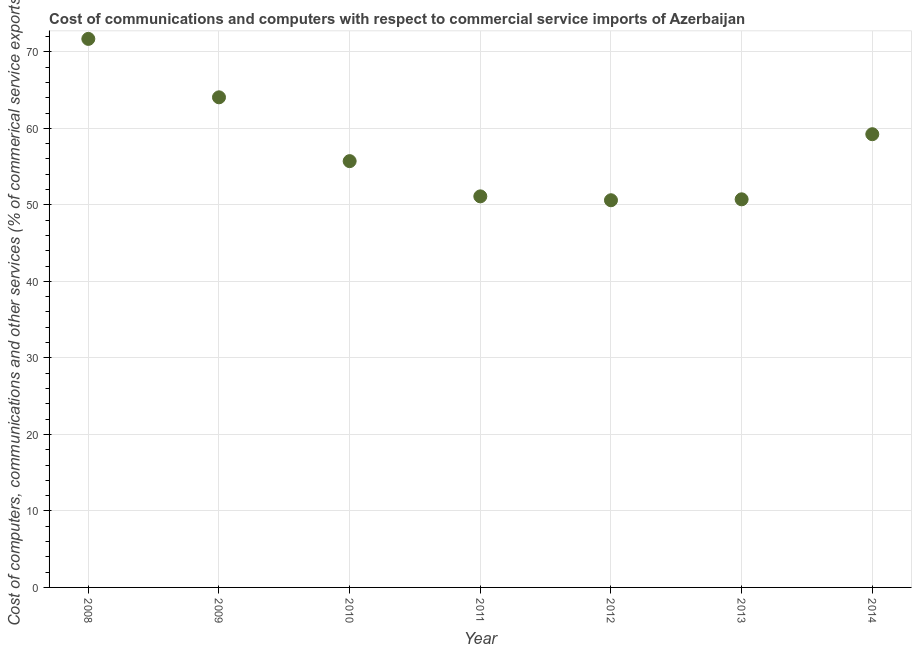What is the cost of communications in 2012?
Your answer should be very brief. 50.6. Across all years, what is the maximum cost of communications?
Provide a succinct answer. 71.69. Across all years, what is the minimum cost of communications?
Your response must be concise. 50.6. In which year was the cost of communications maximum?
Keep it short and to the point. 2008. In which year was the cost of communications minimum?
Provide a short and direct response. 2012. What is the sum of the  computer and other services?
Your answer should be very brief. 403.13. What is the difference between the  computer and other services in 2011 and 2014?
Offer a terse response. -8.12. What is the average  computer and other services per year?
Your response must be concise. 57.59. What is the median  computer and other services?
Your answer should be compact. 55.71. In how many years, is the  computer and other services greater than 52 %?
Offer a very short reply. 4. Do a majority of the years between 2011 and 2013 (inclusive) have  computer and other services greater than 46 %?
Ensure brevity in your answer.  Yes. What is the ratio of the cost of communications in 2013 to that in 2014?
Your answer should be very brief. 0.86. Is the  computer and other services in 2008 less than that in 2010?
Make the answer very short. No. What is the difference between the highest and the second highest cost of communications?
Keep it short and to the point. 7.64. Is the sum of the  computer and other services in 2010 and 2011 greater than the maximum  computer and other services across all years?
Keep it short and to the point. Yes. What is the difference between the highest and the lowest  computer and other services?
Provide a short and direct response. 21.09. In how many years, is the  computer and other services greater than the average  computer and other services taken over all years?
Provide a short and direct response. 3. Does the  computer and other services monotonically increase over the years?
Make the answer very short. No. How many dotlines are there?
Make the answer very short. 1. What is the difference between two consecutive major ticks on the Y-axis?
Provide a succinct answer. 10. Are the values on the major ticks of Y-axis written in scientific E-notation?
Your response must be concise. No. Does the graph contain grids?
Provide a short and direct response. Yes. What is the title of the graph?
Your response must be concise. Cost of communications and computers with respect to commercial service imports of Azerbaijan. What is the label or title of the Y-axis?
Your response must be concise. Cost of computers, communications and other services (% of commerical service exports). What is the Cost of computers, communications and other services (% of commerical service exports) in 2008?
Ensure brevity in your answer.  71.69. What is the Cost of computers, communications and other services (% of commerical service exports) in 2009?
Provide a succinct answer. 64.05. What is the Cost of computers, communications and other services (% of commerical service exports) in 2010?
Your answer should be very brief. 55.71. What is the Cost of computers, communications and other services (% of commerical service exports) in 2011?
Make the answer very short. 51.11. What is the Cost of computers, communications and other services (% of commerical service exports) in 2012?
Ensure brevity in your answer.  50.6. What is the Cost of computers, communications and other services (% of commerical service exports) in 2013?
Your response must be concise. 50.72. What is the Cost of computers, communications and other services (% of commerical service exports) in 2014?
Offer a terse response. 59.23. What is the difference between the Cost of computers, communications and other services (% of commerical service exports) in 2008 and 2009?
Keep it short and to the point. 7.64. What is the difference between the Cost of computers, communications and other services (% of commerical service exports) in 2008 and 2010?
Ensure brevity in your answer.  15.98. What is the difference between the Cost of computers, communications and other services (% of commerical service exports) in 2008 and 2011?
Offer a terse response. 20.58. What is the difference between the Cost of computers, communications and other services (% of commerical service exports) in 2008 and 2012?
Your answer should be compact. 21.09. What is the difference between the Cost of computers, communications and other services (% of commerical service exports) in 2008 and 2013?
Offer a very short reply. 20.97. What is the difference between the Cost of computers, communications and other services (% of commerical service exports) in 2008 and 2014?
Make the answer very short. 12.46. What is the difference between the Cost of computers, communications and other services (% of commerical service exports) in 2009 and 2010?
Ensure brevity in your answer.  8.34. What is the difference between the Cost of computers, communications and other services (% of commerical service exports) in 2009 and 2011?
Offer a very short reply. 12.94. What is the difference between the Cost of computers, communications and other services (% of commerical service exports) in 2009 and 2012?
Give a very brief answer. 13.45. What is the difference between the Cost of computers, communications and other services (% of commerical service exports) in 2009 and 2013?
Make the answer very short. 13.33. What is the difference between the Cost of computers, communications and other services (% of commerical service exports) in 2009 and 2014?
Your answer should be very brief. 4.82. What is the difference between the Cost of computers, communications and other services (% of commerical service exports) in 2010 and 2011?
Provide a short and direct response. 4.6. What is the difference between the Cost of computers, communications and other services (% of commerical service exports) in 2010 and 2012?
Offer a terse response. 5.11. What is the difference between the Cost of computers, communications and other services (% of commerical service exports) in 2010 and 2013?
Your answer should be very brief. 4.99. What is the difference between the Cost of computers, communications and other services (% of commerical service exports) in 2010 and 2014?
Provide a succinct answer. -3.52. What is the difference between the Cost of computers, communications and other services (% of commerical service exports) in 2011 and 2012?
Offer a very short reply. 0.51. What is the difference between the Cost of computers, communications and other services (% of commerical service exports) in 2011 and 2013?
Give a very brief answer. 0.39. What is the difference between the Cost of computers, communications and other services (% of commerical service exports) in 2011 and 2014?
Offer a very short reply. -8.12. What is the difference between the Cost of computers, communications and other services (% of commerical service exports) in 2012 and 2013?
Keep it short and to the point. -0.12. What is the difference between the Cost of computers, communications and other services (% of commerical service exports) in 2012 and 2014?
Your response must be concise. -8.63. What is the difference between the Cost of computers, communications and other services (% of commerical service exports) in 2013 and 2014?
Provide a short and direct response. -8.51. What is the ratio of the Cost of computers, communications and other services (% of commerical service exports) in 2008 to that in 2009?
Provide a short and direct response. 1.12. What is the ratio of the Cost of computers, communications and other services (% of commerical service exports) in 2008 to that in 2010?
Ensure brevity in your answer.  1.29. What is the ratio of the Cost of computers, communications and other services (% of commerical service exports) in 2008 to that in 2011?
Provide a succinct answer. 1.4. What is the ratio of the Cost of computers, communications and other services (% of commerical service exports) in 2008 to that in 2012?
Provide a succinct answer. 1.42. What is the ratio of the Cost of computers, communications and other services (% of commerical service exports) in 2008 to that in 2013?
Make the answer very short. 1.41. What is the ratio of the Cost of computers, communications and other services (% of commerical service exports) in 2008 to that in 2014?
Make the answer very short. 1.21. What is the ratio of the Cost of computers, communications and other services (% of commerical service exports) in 2009 to that in 2010?
Make the answer very short. 1.15. What is the ratio of the Cost of computers, communications and other services (% of commerical service exports) in 2009 to that in 2011?
Offer a terse response. 1.25. What is the ratio of the Cost of computers, communications and other services (% of commerical service exports) in 2009 to that in 2012?
Make the answer very short. 1.27. What is the ratio of the Cost of computers, communications and other services (% of commerical service exports) in 2009 to that in 2013?
Ensure brevity in your answer.  1.26. What is the ratio of the Cost of computers, communications and other services (% of commerical service exports) in 2009 to that in 2014?
Your answer should be compact. 1.08. What is the ratio of the Cost of computers, communications and other services (% of commerical service exports) in 2010 to that in 2011?
Your answer should be compact. 1.09. What is the ratio of the Cost of computers, communications and other services (% of commerical service exports) in 2010 to that in 2012?
Offer a very short reply. 1.1. What is the ratio of the Cost of computers, communications and other services (% of commerical service exports) in 2010 to that in 2013?
Your answer should be compact. 1.1. What is the ratio of the Cost of computers, communications and other services (% of commerical service exports) in 2010 to that in 2014?
Your response must be concise. 0.94. What is the ratio of the Cost of computers, communications and other services (% of commerical service exports) in 2011 to that in 2012?
Provide a short and direct response. 1.01. What is the ratio of the Cost of computers, communications and other services (% of commerical service exports) in 2011 to that in 2013?
Make the answer very short. 1.01. What is the ratio of the Cost of computers, communications and other services (% of commerical service exports) in 2011 to that in 2014?
Give a very brief answer. 0.86. What is the ratio of the Cost of computers, communications and other services (% of commerical service exports) in 2012 to that in 2013?
Your answer should be compact. 1. What is the ratio of the Cost of computers, communications and other services (% of commerical service exports) in 2012 to that in 2014?
Offer a very short reply. 0.85. What is the ratio of the Cost of computers, communications and other services (% of commerical service exports) in 2013 to that in 2014?
Offer a terse response. 0.86. 